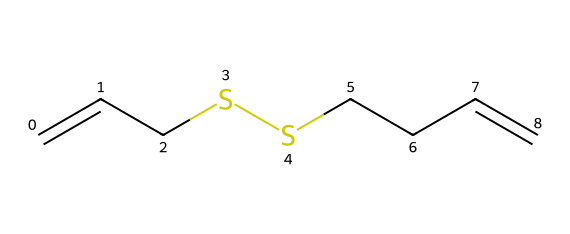What is the molecular formula of diallyl disulfide? To determine the molecular formula, count the number of each type of atom in the SMILES representation. There are 6 carbon (C) atoms, 10 hydrogen (H) atoms, and 2 sulfur (S) atoms, leading to the formula C6H10S2.
Answer: C6H10S2 How many double bonds are present in the molecule? In the SMILES representation, the "=" indicates double bonds. There are 2 occurrences of "C=C," which indicates there are 2 double bonds in the structure.
Answer: 2 What functional groups are present in diallyl disulfide? The structure contains a disulfide (–S–S–) linkage and alkene (C=C) functional groups. Disulfides are characterized by the presence of two sulfur atoms bonded together.
Answer: disulfide and alkene What type of compound is diallyl disulfide? Diallyl disulfide is classified as an organosulfur compound because it contains sulfur atoms covalently bonded to carbon atoms (the definition of organosulfur compounds).
Answer: organosulfur How many carbons are in the longest carbon chain? By examining the structure, the longest continuous carbon chain is made up of 4 carbon atoms connected directly, which spans from one double bond to the next.
Answer: 4 What is the overall hybridization of the carbon atoms in the double bonds? The carbon atoms involved in the double bonds (C=C) are sp2 hybridized because they are bonded to three substituents (two other carbons and one hydrogen) and one double bond.
Answer: sp2 